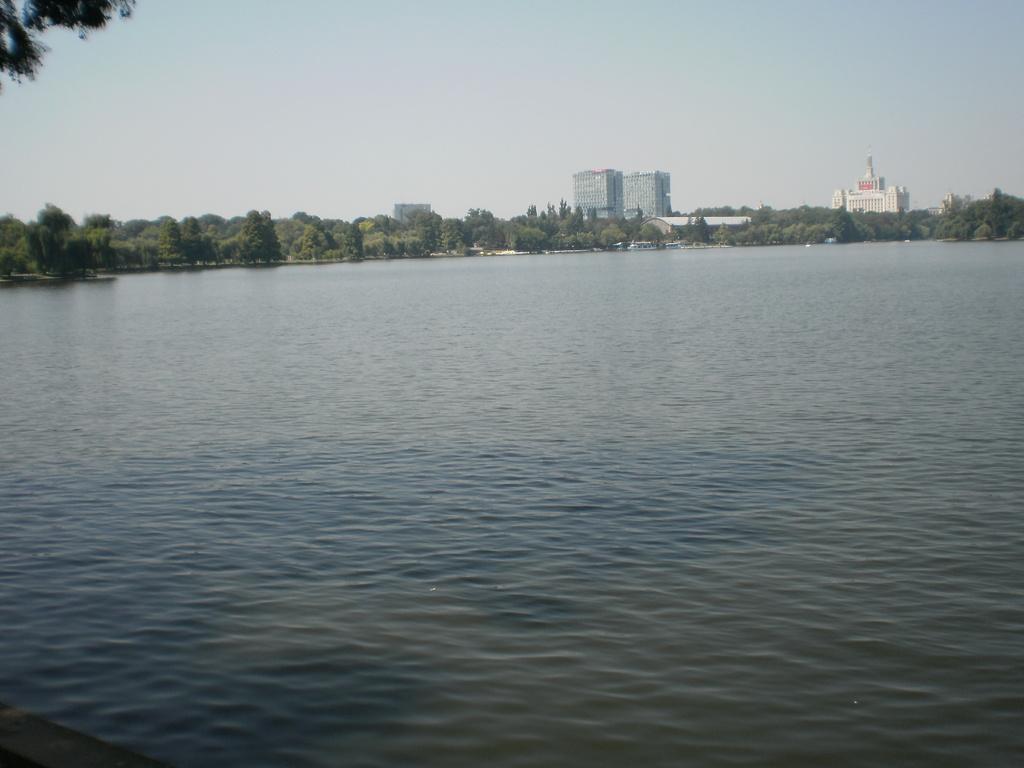In one or two sentences, can you explain what this image depicts? In the foreground there is a water body. In the middle of the picture there are trees and buildings. At the top there is sky. 